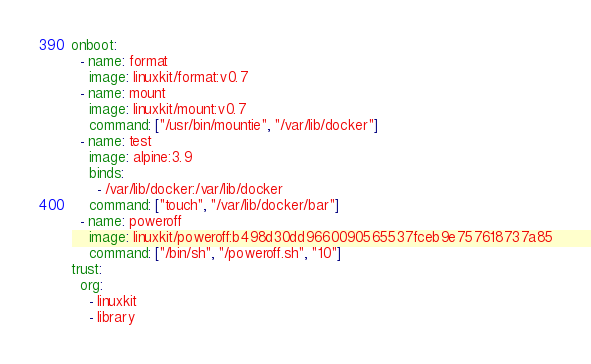<code> <loc_0><loc_0><loc_500><loc_500><_YAML_>onboot:
  - name: format
    image: linuxkit/format:v0.7
  - name: mount
    image: linuxkit/mount:v0.7
    command: ["/usr/bin/mountie", "/var/lib/docker"]
  - name: test
    image: alpine:3.9
    binds:
      - /var/lib/docker:/var/lib/docker
    command: ["touch", "/var/lib/docker/bar"]
  - name: poweroff
    image: linuxkit/poweroff:b498d30dd9660090565537fceb9e757618737a85
    command: ["/bin/sh", "/poweroff.sh", "10"]
trust:
  org: 
    - linuxkit
    - library
</code> 